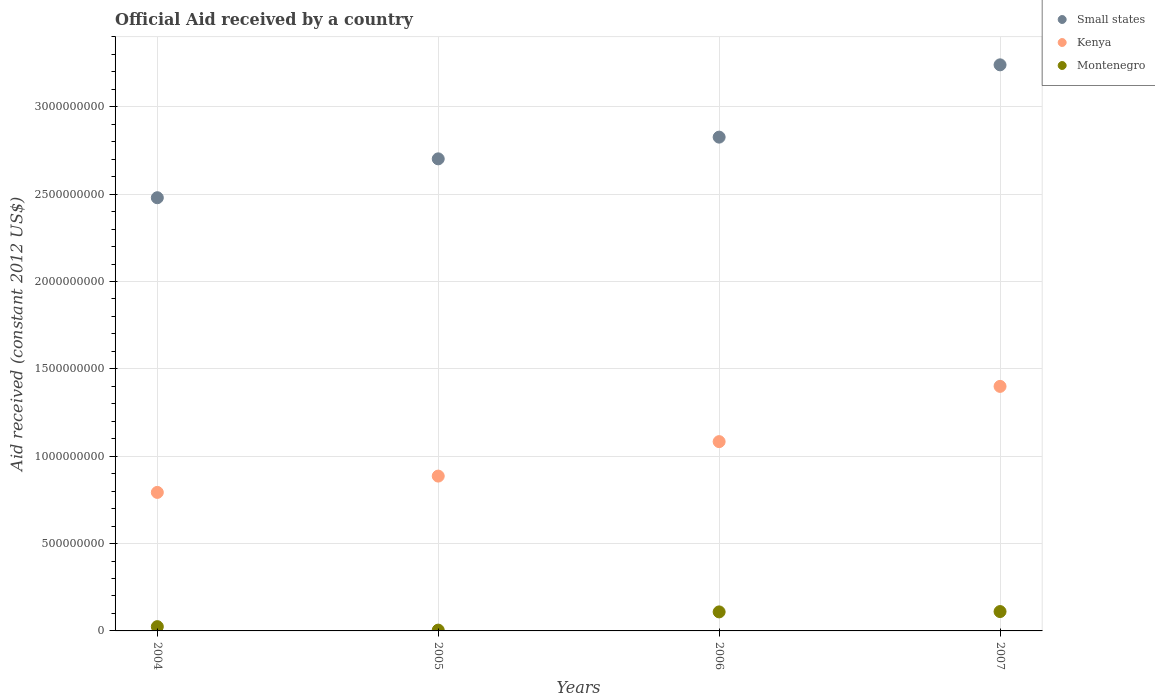What is the net official aid received in Kenya in 2007?
Provide a short and direct response. 1.40e+09. Across all years, what is the maximum net official aid received in Kenya?
Make the answer very short. 1.40e+09. Across all years, what is the minimum net official aid received in Montenegro?
Your answer should be very brief. 4.58e+06. In which year was the net official aid received in Montenegro minimum?
Offer a very short reply. 2005. What is the total net official aid received in Montenegro in the graph?
Ensure brevity in your answer.  2.49e+08. What is the difference between the net official aid received in Montenegro in 2005 and that in 2007?
Your answer should be compact. -1.06e+08. What is the difference between the net official aid received in Small states in 2006 and the net official aid received in Montenegro in 2007?
Provide a short and direct response. 2.72e+09. What is the average net official aid received in Small states per year?
Give a very brief answer. 2.81e+09. In the year 2007, what is the difference between the net official aid received in Montenegro and net official aid received in Kenya?
Offer a very short reply. -1.29e+09. In how many years, is the net official aid received in Kenya greater than 800000000 US$?
Provide a succinct answer. 3. What is the ratio of the net official aid received in Kenya in 2005 to that in 2007?
Make the answer very short. 0.63. Is the net official aid received in Montenegro in 2005 less than that in 2007?
Your answer should be compact. Yes. Is the difference between the net official aid received in Montenegro in 2005 and 2006 greater than the difference between the net official aid received in Kenya in 2005 and 2006?
Offer a very short reply. Yes. What is the difference between the highest and the second highest net official aid received in Small states?
Give a very brief answer. 4.14e+08. What is the difference between the highest and the lowest net official aid received in Montenegro?
Give a very brief answer. 1.06e+08. In how many years, is the net official aid received in Small states greater than the average net official aid received in Small states taken over all years?
Your answer should be compact. 2. Is the sum of the net official aid received in Small states in 2005 and 2006 greater than the maximum net official aid received in Kenya across all years?
Offer a very short reply. Yes. Is it the case that in every year, the sum of the net official aid received in Small states and net official aid received in Montenegro  is greater than the net official aid received in Kenya?
Your answer should be very brief. Yes. Is the net official aid received in Montenegro strictly greater than the net official aid received in Kenya over the years?
Your response must be concise. No. Is the net official aid received in Small states strictly less than the net official aid received in Montenegro over the years?
Your response must be concise. No. What is the difference between two consecutive major ticks on the Y-axis?
Offer a very short reply. 5.00e+08. Are the values on the major ticks of Y-axis written in scientific E-notation?
Provide a succinct answer. No. Does the graph contain grids?
Offer a terse response. Yes. Where does the legend appear in the graph?
Give a very brief answer. Top right. How many legend labels are there?
Keep it short and to the point. 3. How are the legend labels stacked?
Keep it short and to the point. Vertical. What is the title of the graph?
Offer a very short reply. Official Aid received by a country. Does "Philippines" appear as one of the legend labels in the graph?
Offer a terse response. No. What is the label or title of the Y-axis?
Offer a very short reply. Aid received (constant 2012 US$). What is the Aid received (constant 2012 US$) in Small states in 2004?
Your response must be concise. 2.48e+09. What is the Aid received (constant 2012 US$) in Kenya in 2004?
Keep it short and to the point. 7.93e+08. What is the Aid received (constant 2012 US$) in Montenegro in 2004?
Give a very brief answer. 2.45e+07. What is the Aid received (constant 2012 US$) of Small states in 2005?
Give a very brief answer. 2.70e+09. What is the Aid received (constant 2012 US$) in Kenya in 2005?
Keep it short and to the point. 8.86e+08. What is the Aid received (constant 2012 US$) of Montenegro in 2005?
Ensure brevity in your answer.  4.58e+06. What is the Aid received (constant 2012 US$) of Small states in 2006?
Ensure brevity in your answer.  2.83e+09. What is the Aid received (constant 2012 US$) of Kenya in 2006?
Your response must be concise. 1.08e+09. What is the Aid received (constant 2012 US$) of Montenegro in 2006?
Provide a succinct answer. 1.09e+08. What is the Aid received (constant 2012 US$) in Small states in 2007?
Give a very brief answer. 3.24e+09. What is the Aid received (constant 2012 US$) in Kenya in 2007?
Ensure brevity in your answer.  1.40e+09. What is the Aid received (constant 2012 US$) in Montenegro in 2007?
Your answer should be compact. 1.11e+08. Across all years, what is the maximum Aid received (constant 2012 US$) in Small states?
Your answer should be very brief. 3.24e+09. Across all years, what is the maximum Aid received (constant 2012 US$) of Kenya?
Your response must be concise. 1.40e+09. Across all years, what is the maximum Aid received (constant 2012 US$) in Montenegro?
Your response must be concise. 1.11e+08. Across all years, what is the minimum Aid received (constant 2012 US$) in Small states?
Offer a terse response. 2.48e+09. Across all years, what is the minimum Aid received (constant 2012 US$) in Kenya?
Keep it short and to the point. 7.93e+08. Across all years, what is the minimum Aid received (constant 2012 US$) in Montenegro?
Keep it short and to the point. 4.58e+06. What is the total Aid received (constant 2012 US$) of Small states in the graph?
Your response must be concise. 1.12e+1. What is the total Aid received (constant 2012 US$) of Kenya in the graph?
Offer a very short reply. 4.16e+09. What is the total Aid received (constant 2012 US$) in Montenegro in the graph?
Make the answer very short. 2.49e+08. What is the difference between the Aid received (constant 2012 US$) in Small states in 2004 and that in 2005?
Provide a short and direct response. -2.23e+08. What is the difference between the Aid received (constant 2012 US$) in Kenya in 2004 and that in 2005?
Your response must be concise. -9.34e+07. What is the difference between the Aid received (constant 2012 US$) of Montenegro in 2004 and that in 2005?
Keep it short and to the point. 1.99e+07. What is the difference between the Aid received (constant 2012 US$) of Small states in 2004 and that in 2006?
Your response must be concise. -3.47e+08. What is the difference between the Aid received (constant 2012 US$) of Kenya in 2004 and that in 2006?
Keep it short and to the point. -2.91e+08. What is the difference between the Aid received (constant 2012 US$) of Montenegro in 2004 and that in 2006?
Your answer should be compact. -8.44e+07. What is the difference between the Aid received (constant 2012 US$) of Small states in 2004 and that in 2007?
Your answer should be very brief. -7.61e+08. What is the difference between the Aid received (constant 2012 US$) of Kenya in 2004 and that in 2007?
Ensure brevity in your answer.  -6.07e+08. What is the difference between the Aid received (constant 2012 US$) of Montenegro in 2004 and that in 2007?
Give a very brief answer. -8.63e+07. What is the difference between the Aid received (constant 2012 US$) in Small states in 2005 and that in 2006?
Ensure brevity in your answer.  -1.24e+08. What is the difference between the Aid received (constant 2012 US$) in Kenya in 2005 and that in 2006?
Provide a short and direct response. -1.97e+08. What is the difference between the Aid received (constant 2012 US$) in Montenegro in 2005 and that in 2006?
Provide a succinct answer. -1.04e+08. What is the difference between the Aid received (constant 2012 US$) of Small states in 2005 and that in 2007?
Your response must be concise. -5.38e+08. What is the difference between the Aid received (constant 2012 US$) in Kenya in 2005 and that in 2007?
Make the answer very short. -5.13e+08. What is the difference between the Aid received (constant 2012 US$) in Montenegro in 2005 and that in 2007?
Give a very brief answer. -1.06e+08. What is the difference between the Aid received (constant 2012 US$) in Small states in 2006 and that in 2007?
Make the answer very short. -4.14e+08. What is the difference between the Aid received (constant 2012 US$) of Kenya in 2006 and that in 2007?
Keep it short and to the point. -3.16e+08. What is the difference between the Aid received (constant 2012 US$) of Montenegro in 2006 and that in 2007?
Offer a very short reply. -1.90e+06. What is the difference between the Aid received (constant 2012 US$) of Small states in 2004 and the Aid received (constant 2012 US$) of Kenya in 2005?
Keep it short and to the point. 1.59e+09. What is the difference between the Aid received (constant 2012 US$) of Small states in 2004 and the Aid received (constant 2012 US$) of Montenegro in 2005?
Your answer should be compact. 2.47e+09. What is the difference between the Aid received (constant 2012 US$) of Kenya in 2004 and the Aid received (constant 2012 US$) of Montenegro in 2005?
Your response must be concise. 7.88e+08. What is the difference between the Aid received (constant 2012 US$) in Small states in 2004 and the Aid received (constant 2012 US$) in Kenya in 2006?
Your answer should be compact. 1.40e+09. What is the difference between the Aid received (constant 2012 US$) of Small states in 2004 and the Aid received (constant 2012 US$) of Montenegro in 2006?
Your answer should be very brief. 2.37e+09. What is the difference between the Aid received (constant 2012 US$) of Kenya in 2004 and the Aid received (constant 2012 US$) of Montenegro in 2006?
Provide a short and direct response. 6.84e+08. What is the difference between the Aid received (constant 2012 US$) of Small states in 2004 and the Aid received (constant 2012 US$) of Kenya in 2007?
Make the answer very short. 1.08e+09. What is the difference between the Aid received (constant 2012 US$) of Small states in 2004 and the Aid received (constant 2012 US$) of Montenegro in 2007?
Ensure brevity in your answer.  2.37e+09. What is the difference between the Aid received (constant 2012 US$) of Kenya in 2004 and the Aid received (constant 2012 US$) of Montenegro in 2007?
Provide a short and direct response. 6.82e+08. What is the difference between the Aid received (constant 2012 US$) of Small states in 2005 and the Aid received (constant 2012 US$) of Kenya in 2006?
Keep it short and to the point. 1.62e+09. What is the difference between the Aid received (constant 2012 US$) of Small states in 2005 and the Aid received (constant 2012 US$) of Montenegro in 2006?
Keep it short and to the point. 2.59e+09. What is the difference between the Aid received (constant 2012 US$) of Kenya in 2005 and the Aid received (constant 2012 US$) of Montenegro in 2006?
Provide a succinct answer. 7.77e+08. What is the difference between the Aid received (constant 2012 US$) of Small states in 2005 and the Aid received (constant 2012 US$) of Kenya in 2007?
Your answer should be compact. 1.30e+09. What is the difference between the Aid received (constant 2012 US$) in Small states in 2005 and the Aid received (constant 2012 US$) in Montenegro in 2007?
Offer a terse response. 2.59e+09. What is the difference between the Aid received (constant 2012 US$) of Kenya in 2005 and the Aid received (constant 2012 US$) of Montenegro in 2007?
Your answer should be compact. 7.75e+08. What is the difference between the Aid received (constant 2012 US$) of Small states in 2006 and the Aid received (constant 2012 US$) of Kenya in 2007?
Offer a terse response. 1.43e+09. What is the difference between the Aid received (constant 2012 US$) of Small states in 2006 and the Aid received (constant 2012 US$) of Montenegro in 2007?
Your answer should be very brief. 2.72e+09. What is the difference between the Aid received (constant 2012 US$) of Kenya in 2006 and the Aid received (constant 2012 US$) of Montenegro in 2007?
Your response must be concise. 9.73e+08. What is the average Aid received (constant 2012 US$) of Small states per year?
Make the answer very short. 2.81e+09. What is the average Aid received (constant 2012 US$) of Kenya per year?
Your answer should be compact. 1.04e+09. What is the average Aid received (constant 2012 US$) in Montenegro per year?
Ensure brevity in your answer.  6.22e+07. In the year 2004, what is the difference between the Aid received (constant 2012 US$) of Small states and Aid received (constant 2012 US$) of Kenya?
Give a very brief answer. 1.69e+09. In the year 2004, what is the difference between the Aid received (constant 2012 US$) in Small states and Aid received (constant 2012 US$) in Montenegro?
Your answer should be very brief. 2.46e+09. In the year 2004, what is the difference between the Aid received (constant 2012 US$) in Kenya and Aid received (constant 2012 US$) in Montenegro?
Your response must be concise. 7.68e+08. In the year 2005, what is the difference between the Aid received (constant 2012 US$) in Small states and Aid received (constant 2012 US$) in Kenya?
Offer a terse response. 1.82e+09. In the year 2005, what is the difference between the Aid received (constant 2012 US$) in Small states and Aid received (constant 2012 US$) in Montenegro?
Offer a terse response. 2.70e+09. In the year 2005, what is the difference between the Aid received (constant 2012 US$) in Kenya and Aid received (constant 2012 US$) in Montenegro?
Your answer should be compact. 8.82e+08. In the year 2006, what is the difference between the Aid received (constant 2012 US$) in Small states and Aid received (constant 2012 US$) in Kenya?
Provide a succinct answer. 1.74e+09. In the year 2006, what is the difference between the Aid received (constant 2012 US$) in Small states and Aid received (constant 2012 US$) in Montenegro?
Provide a succinct answer. 2.72e+09. In the year 2006, what is the difference between the Aid received (constant 2012 US$) of Kenya and Aid received (constant 2012 US$) of Montenegro?
Your response must be concise. 9.75e+08. In the year 2007, what is the difference between the Aid received (constant 2012 US$) of Small states and Aid received (constant 2012 US$) of Kenya?
Your answer should be very brief. 1.84e+09. In the year 2007, what is the difference between the Aid received (constant 2012 US$) in Small states and Aid received (constant 2012 US$) in Montenegro?
Your answer should be very brief. 3.13e+09. In the year 2007, what is the difference between the Aid received (constant 2012 US$) of Kenya and Aid received (constant 2012 US$) of Montenegro?
Make the answer very short. 1.29e+09. What is the ratio of the Aid received (constant 2012 US$) of Small states in 2004 to that in 2005?
Your response must be concise. 0.92. What is the ratio of the Aid received (constant 2012 US$) in Kenya in 2004 to that in 2005?
Give a very brief answer. 0.89. What is the ratio of the Aid received (constant 2012 US$) in Montenegro in 2004 to that in 2005?
Your answer should be very brief. 5.35. What is the ratio of the Aid received (constant 2012 US$) of Small states in 2004 to that in 2006?
Make the answer very short. 0.88. What is the ratio of the Aid received (constant 2012 US$) of Kenya in 2004 to that in 2006?
Keep it short and to the point. 0.73. What is the ratio of the Aid received (constant 2012 US$) in Montenegro in 2004 to that in 2006?
Offer a very short reply. 0.23. What is the ratio of the Aid received (constant 2012 US$) in Small states in 2004 to that in 2007?
Offer a terse response. 0.77. What is the ratio of the Aid received (constant 2012 US$) in Kenya in 2004 to that in 2007?
Your answer should be compact. 0.57. What is the ratio of the Aid received (constant 2012 US$) in Montenegro in 2004 to that in 2007?
Give a very brief answer. 0.22. What is the ratio of the Aid received (constant 2012 US$) of Small states in 2005 to that in 2006?
Make the answer very short. 0.96. What is the ratio of the Aid received (constant 2012 US$) in Kenya in 2005 to that in 2006?
Offer a terse response. 0.82. What is the ratio of the Aid received (constant 2012 US$) of Montenegro in 2005 to that in 2006?
Ensure brevity in your answer.  0.04. What is the ratio of the Aid received (constant 2012 US$) in Small states in 2005 to that in 2007?
Your response must be concise. 0.83. What is the ratio of the Aid received (constant 2012 US$) in Kenya in 2005 to that in 2007?
Your answer should be very brief. 0.63. What is the ratio of the Aid received (constant 2012 US$) in Montenegro in 2005 to that in 2007?
Provide a succinct answer. 0.04. What is the ratio of the Aid received (constant 2012 US$) of Small states in 2006 to that in 2007?
Ensure brevity in your answer.  0.87. What is the ratio of the Aid received (constant 2012 US$) of Kenya in 2006 to that in 2007?
Offer a terse response. 0.77. What is the ratio of the Aid received (constant 2012 US$) of Montenegro in 2006 to that in 2007?
Your answer should be very brief. 0.98. What is the difference between the highest and the second highest Aid received (constant 2012 US$) in Small states?
Keep it short and to the point. 4.14e+08. What is the difference between the highest and the second highest Aid received (constant 2012 US$) in Kenya?
Provide a succinct answer. 3.16e+08. What is the difference between the highest and the second highest Aid received (constant 2012 US$) in Montenegro?
Keep it short and to the point. 1.90e+06. What is the difference between the highest and the lowest Aid received (constant 2012 US$) of Small states?
Give a very brief answer. 7.61e+08. What is the difference between the highest and the lowest Aid received (constant 2012 US$) of Kenya?
Give a very brief answer. 6.07e+08. What is the difference between the highest and the lowest Aid received (constant 2012 US$) in Montenegro?
Provide a short and direct response. 1.06e+08. 